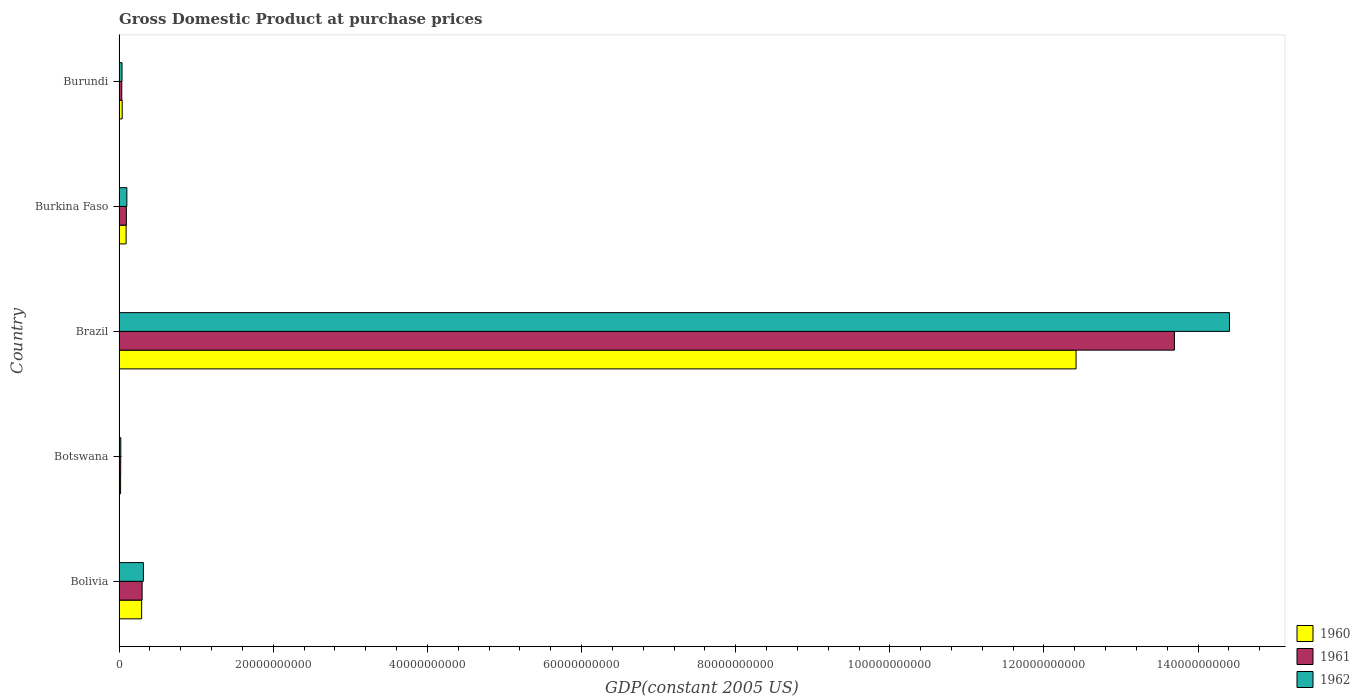How many groups of bars are there?
Your answer should be compact. 5. How many bars are there on the 1st tick from the top?
Make the answer very short. 3. How many bars are there on the 4th tick from the bottom?
Your answer should be compact. 3. What is the label of the 4th group of bars from the top?
Make the answer very short. Botswana. What is the GDP at purchase prices in 1961 in Burundi?
Your answer should be very brief. 3.53e+08. Across all countries, what is the maximum GDP at purchase prices in 1962?
Your response must be concise. 1.44e+11. Across all countries, what is the minimum GDP at purchase prices in 1961?
Your answer should be very brief. 2.12e+08. In which country was the GDP at purchase prices in 1962 minimum?
Your answer should be compact. Botswana. What is the total GDP at purchase prices in 1961 in the graph?
Ensure brevity in your answer.  1.41e+11. What is the difference between the GDP at purchase prices in 1962 in Botswana and that in Brazil?
Offer a very short reply. -1.44e+11. What is the difference between the GDP at purchase prices in 1961 in Burkina Faso and the GDP at purchase prices in 1962 in Burundi?
Give a very brief answer. 5.69e+08. What is the average GDP at purchase prices in 1960 per country?
Give a very brief answer. 2.57e+1. What is the difference between the GDP at purchase prices in 1961 and GDP at purchase prices in 1962 in Brazil?
Your answer should be very brief. -7.14e+09. What is the ratio of the GDP at purchase prices in 1960 in Brazil to that in Burundi?
Provide a succinct answer. 303.09. What is the difference between the highest and the second highest GDP at purchase prices in 1960?
Give a very brief answer. 1.21e+11. What is the difference between the highest and the lowest GDP at purchase prices in 1961?
Provide a short and direct response. 1.37e+11. Is the sum of the GDP at purchase prices in 1962 in Brazil and Burundi greater than the maximum GDP at purchase prices in 1960 across all countries?
Give a very brief answer. Yes. What does the 2nd bar from the top in Brazil represents?
Give a very brief answer. 1961. Is it the case that in every country, the sum of the GDP at purchase prices in 1961 and GDP at purchase prices in 1962 is greater than the GDP at purchase prices in 1960?
Your answer should be compact. Yes. Are all the bars in the graph horizontal?
Provide a succinct answer. Yes. How many countries are there in the graph?
Offer a terse response. 5. How many legend labels are there?
Provide a succinct answer. 3. What is the title of the graph?
Make the answer very short. Gross Domestic Product at purchase prices. Does "2012" appear as one of the legend labels in the graph?
Your answer should be compact. No. What is the label or title of the X-axis?
Offer a terse response. GDP(constant 2005 US). What is the GDP(constant 2005 US) in 1960 in Bolivia?
Ensure brevity in your answer.  2.93e+09. What is the GDP(constant 2005 US) in 1961 in Bolivia?
Make the answer very short. 2.99e+09. What is the GDP(constant 2005 US) in 1962 in Bolivia?
Provide a short and direct response. 3.16e+09. What is the GDP(constant 2005 US) in 1960 in Botswana?
Make the answer very short. 1.99e+08. What is the GDP(constant 2005 US) in 1961 in Botswana?
Your response must be concise. 2.12e+08. What is the GDP(constant 2005 US) of 1962 in Botswana?
Your answer should be very brief. 2.26e+08. What is the GDP(constant 2005 US) of 1960 in Brazil?
Keep it short and to the point. 1.24e+11. What is the GDP(constant 2005 US) in 1961 in Brazil?
Give a very brief answer. 1.37e+11. What is the GDP(constant 2005 US) of 1962 in Brazil?
Provide a short and direct response. 1.44e+11. What is the GDP(constant 2005 US) in 1960 in Burkina Faso?
Make the answer very short. 9.17e+08. What is the GDP(constant 2005 US) of 1961 in Burkina Faso?
Offer a terse response. 9.54e+08. What is the GDP(constant 2005 US) in 1962 in Burkina Faso?
Ensure brevity in your answer.  1.01e+09. What is the GDP(constant 2005 US) of 1960 in Burundi?
Provide a short and direct response. 4.10e+08. What is the GDP(constant 2005 US) of 1961 in Burundi?
Ensure brevity in your answer.  3.53e+08. What is the GDP(constant 2005 US) in 1962 in Burundi?
Keep it short and to the point. 3.85e+08. Across all countries, what is the maximum GDP(constant 2005 US) in 1960?
Provide a succinct answer. 1.24e+11. Across all countries, what is the maximum GDP(constant 2005 US) of 1961?
Your response must be concise. 1.37e+11. Across all countries, what is the maximum GDP(constant 2005 US) in 1962?
Keep it short and to the point. 1.44e+11. Across all countries, what is the minimum GDP(constant 2005 US) of 1960?
Provide a short and direct response. 1.99e+08. Across all countries, what is the minimum GDP(constant 2005 US) in 1961?
Your answer should be very brief. 2.12e+08. Across all countries, what is the minimum GDP(constant 2005 US) in 1962?
Offer a very short reply. 2.26e+08. What is the total GDP(constant 2005 US) in 1960 in the graph?
Your answer should be very brief. 1.29e+11. What is the total GDP(constant 2005 US) of 1961 in the graph?
Offer a terse response. 1.41e+11. What is the total GDP(constant 2005 US) of 1962 in the graph?
Provide a short and direct response. 1.49e+11. What is the difference between the GDP(constant 2005 US) of 1960 in Bolivia and that in Botswana?
Give a very brief answer. 2.73e+09. What is the difference between the GDP(constant 2005 US) of 1961 in Bolivia and that in Botswana?
Your response must be concise. 2.78e+09. What is the difference between the GDP(constant 2005 US) of 1962 in Bolivia and that in Botswana?
Provide a succinct answer. 2.93e+09. What is the difference between the GDP(constant 2005 US) of 1960 in Bolivia and that in Brazil?
Your response must be concise. -1.21e+11. What is the difference between the GDP(constant 2005 US) in 1961 in Bolivia and that in Brazil?
Provide a short and direct response. -1.34e+11. What is the difference between the GDP(constant 2005 US) in 1962 in Bolivia and that in Brazil?
Offer a terse response. -1.41e+11. What is the difference between the GDP(constant 2005 US) in 1960 in Bolivia and that in Burkina Faso?
Your answer should be compact. 2.01e+09. What is the difference between the GDP(constant 2005 US) in 1961 in Bolivia and that in Burkina Faso?
Provide a succinct answer. 2.04e+09. What is the difference between the GDP(constant 2005 US) of 1962 in Bolivia and that in Burkina Faso?
Provide a short and direct response. 2.15e+09. What is the difference between the GDP(constant 2005 US) in 1960 in Bolivia and that in Burundi?
Provide a short and direct response. 2.52e+09. What is the difference between the GDP(constant 2005 US) in 1961 in Bolivia and that in Burundi?
Make the answer very short. 2.64e+09. What is the difference between the GDP(constant 2005 US) of 1962 in Bolivia and that in Burundi?
Keep it short and to the point. 2.77e+09. What is the difference between the GDP(constant 2005 US) of 1960 in Botswana and that in Brazil?
Offer a very short reply. -1.24e+11. What is the difference between the GDP(constant 2005 US) in 1961 in Botswana and that in Brazil?
Your answer should be very brief. -1.37e+11. What is the difference between the GDP(constant 2005 US) of 1962 in Botswana and that in Brazil?
Offer a very short reply. -1.44e+11. What is the difference between the GDP(constant 2005 US) of 1960 in Botswana and that in Burkina Faso?
Your answer should be very brief. -7.18e+08. What is the difference between the GDP(constant 2005 US) in 1961 in Botswana and that in Burkina Faso?
Give a very brief answer. -7.42e+08. What is the difference between the GDP(constant 2005 US) of 1962 in Botswana and that in Burkina Faso?
Your response must be concise. -7.87e+08. What is the difference between the GDP(constant 2005 US) of 1960 in Botswana and that in Burundi?
Keep it short and to the point. -2.11e+08. What is the difference between the GDP(constant 2005 US) in 1961 in Botswana and that in Burundi?
Keep it short and to the point. -1.42e+08. What is the difference between the GDP(constant 2005 US) of 1962 in Botswana and that in Burundi?
Provide a short and direct response. -1.60e+08. What is the difference between the GDP(constant 2005 US) in 1960 in Brazil and that in Burkina Faso?
Offer a terse response. 1.23e+11. What is the difference between the GDP(constant 2005 US) in 1961 in Brazil and that in Burkina Faso?
Your answer should be compact. 1.36e+11. What is the difference between the GDP(constant 2005 US) of 1962 in Brazil and that in Burkina Faso?
Provide a succinct answer. 1.43e+11. What is the difference between the GDP(constant 2005 US) of 1960 in Brazil and that in Burundi?
Keep it short and to the point. 1.24e+11. What is the difference between the GDP(constant 2005 US) of 1961 in Brazil and that in Burundi?
Your answer should be compact. 1.37e+11. What is the difference between the GDP(constant 2005 US) in 1962 in Brazil and that in Burundi?
Give a very brief answer. 1.44e+11. What is the difference between the GDP(constant 2005 US) of 1960 in Burkina Faso and that in Burundi?
Make the answer very short. 5.07e+08. What is the difference between the GDP(constant 2005 US) in 1961 in Burkina Faso and that in Burundi?
Your response must be concise. 6.01e+08. What is the difference between the GDP(constant 2005 US) of 1962 in Burkina Faso and that in Burundi?
Your answer should be compact. 6.27e+08. What is the difference between the GDP(constant 2005 US) of 1960 in Bolivia and the GDP(constant 2005 US) of 1961 in Botswana?
Provide a short and direct response. 2.72e+09. What is the difference between the GDP(constant 2005 US) of 1960 in Bolivia and the GDP(constant 2005 US) of 1962 in Botswana?
Provide a short and direct response. 2.71e+09. What is the difference between the GDP(constant 2005 US) in 1961 in Bolivia and the GDP(constant 2005 US) in 1962 in Botswana?
Ensure brevity in your answer.  2.77e+09. What is the difference between the GDP(constant 2005 US) of 1960 in Bolivia and the GDP(constant 2005 US) of 1961 in Brazil?
Provide a succinct answer. -1.34e+11. What is the difference between the GDP(constant 2005 US) of 1960 in Bolivia and the GDP(constant 2005 US) of 1962 in Brazil?
Your answer should be compact. -1.41e+11. What is the difference between the GDP(constant 2005 US) in 1961 in Bolivia and the GDP(constant 2005 US) in 1962 in Brazil?
Your answer should be compact. -1.41e+11. What is the difference between the GDP(constant 2005 US) in 1960 in Bolivia and the GDP(constant 2005 US) in 1961 in Burkina Faso?
Provide a succinct answer. 1.98e+09. What is the difference between the GDP(constant 2005 US) of 1960 in Bolivia and the GDP(constant 2005 US) of 1962 in Burkina Faso?
Provide a short and direct response. 1.92e+09. What is the difference between the GDP(constant 2005 US) of 1961 in Bolivia and the GDP(constant 2005 US) of 1962 in Burkina Faso?
Your answer should be compact. 1.98e+09. What is the difference between the GDP(constant 2005 US) in 1960 in Bolivia and the GDP(constant 2005 US) in 1961 in Burundi?
Keep it short and to the point. 2.58e+09. What is the difference between the GDP(constant 2005 US) of 1960 in Bolivia and the GDP(constant 2005 US) of 1962 in Burundi?
Provide a short and direct response. 2.55e+09. What is the difference between the GDP(constant 2005 US) of 1961 in Bolivia and the GDP(constant 2005 US) of 1962 in Burundi?
Your answer should be compact. 2.61e+09. What is the difference between the GDP(constant 2005 US) in 1960 in Botswana and the GDP(constant 2005 US) in 1961 in Brazil?
Ensure brevity in your answer.  -1.37e+11. What is the difference between the GDP(constant 2005 US) of 1960 in Botswana and the GDP(constant 2005 US) of 1962 in Brazil?
Your response must be concise. -1.44e+11. What is the difference between the GDP(constant 2005 US) in 1961 in Botswana and the GDP(constant 2005 US) in 1962 in Brazil?
Your answer should be very brief. -1.44e+11. What is the difference between the GDP(constant 2005 US) of 1960 in Botswana and the GDP(constant 2005 US) of 1961 in Burkina Faso?
Keep it short and to the point. -7.55e+08. What is the difference between the GDP(constant 2005 US) of 1960 in Botswana and the GDP(constant 2005 US) of 1962 in Burkina Faso?
Ensure brevity in your answer.  -8.14e+08. What is the difference between the GDP(constant 2005 US) of 1961 in Botswana and the GDP(constant 2005 US) of 1962 in Burkina Faso?
Provide a succinct answer. -8.01e+08. What is the difference between the GDP(constant 2005 US) of 1960 in Botswana and the GDP(constant 2005 US) of 1961 in Burundi?
Make the answer very short. -1.54e+08. What is the difference between the GDP(constant 2005 US) of 1960 in Botswana and the GDP(constant 2005 US) of 1962 in Burundi?
Offer a very short reply. -1.86e+08. What is the difference between the GDP(constant 2005 US) of 1961 in Botswana and the GDP(constant 2005 US) of 1962 in Burundi?
Offer a very short reply. -1.74e+08. What is the difference between the GDP(constant 2005 US) of 1960 in Brazil and the GDP(constant 2005 US) of 1961 in Burkina Faso?
Your response must be concise. 1.23e+11. What is the difference between the GDP(constant 2005 US) in 1960 in Brazil and the GDP(constant 2005 US) in 1962 in Burkina Faso?
Provide a succinct answer. 1.23e+11. What is the difference between the GDP(constant 2005 US) of 1961 in Brazil and the GDP(constant 2005 US) of 1962 in Burkina Faso?
Ensure brevity in your answer.  1.36e+11. What is the difference between the GDP(constant 2005 US) of 1960 in Brazil and the GDP(constant 2005 US) of 1961 in Burundi?
Provide a succinct answer. 1.24e+11. What is the difference between the GDP(constant 2005 US) in 1960 in Brazil and the GDP(constant 2005 US) in 1962 in Burundi?
Your response must be concise. 1.24e+11. What is the difference between the GDP(constant 2005 US) of 1961 in Brazil and the GDP(constant 2005 US) of 1962 in Burundi?
Provide a short and direct response. 1.37e+11. What is the difference between the GDP(constant 2005 US) of 1960 in Burkina Faso and the GDP(constant 2005 US) of 1961 in Burundi?
Ensure brevity in your answer.  5.64e+08. What is the difference between the GDP(constant 2005 US) in 1960 in Burkina Faso and the GDP(constant 2005 US) in 1962 in Burundi?
Make the answer very short. 5.32e+08. What is the difference between the GDP(constant 2005 US) in 1961 in Burkina Faso and the GDP(constant 2005 US) in 1962 in Burundi?
Your answer should be compact. 5.69e+08. What is the average GDP(constant 2005 US) in 1960 per country?
Keep it short and to the point. 2.57e+1. What is the average GDP(constant 2005 US) in 1961 per country?
Provide a short and direct response. 2.83e+1. What is the average GDP(constant 2005 US) of 1962 per country?
Make the answer very short. 2.98e+1. What is the difference between the GDP(constant 2005 US) in 1960 and GDP(constant 2005 US) in 1961 in Bolivia?
Offer a terse response. -6.10e+07. What is the difference between the GDP(constant 2005 US) of 1960 and GDP(constant 2005 US) of 1962 in Bolivia?
Offer a very short reply. -2.28e+08. What is the difference between the GDP(constant 2005 US) of 1961 and GDP(constant 2005 US) of 1962 in Bolivia?
Offer a very short reply. -1.67e+08. What is the difference between the GDP(constant 2005 US) of 1960 and GDP(constant 2005 US) of 1961 in Botswana?
Your response must be concise. -1.26e+07. What is the difference between the GDP(constant 2005 US) in 1960 and GDP(constant 2005 US) in 1962 in Botswana?
Keep it short and to the point. -2.67e+07. What is the difference between the GDP(constant 2005 US) in 1961 and GDP(constant 2005 US) in 1962 in Botswana?
Offer a terse response. -1.41e+07. What is the difference between the GDP(constant 2005 US) of 1960 and GDP(constant 2005 US) of 1961 in Brazil?
Give a very brief answer. -1.28e+1. What is the difference between the GDP(constant 2005 US) of 1960 and GDP(constant 2005 US) of 1962 in Brazil?
Provide a short and direct response. -1.99e+1. What is the difference between the GDP(constant 2005 US) in 1961 and GDP(constant 2005 US) in 1962 in Brazil?
Give a very brief answer. -7.14e+09. What is the difference between the GDP(constant 2005 US) of 1960 and GDP(constant 2005 US) of 1961 in Burkina Faso?
Your answer should be very brief. -3.71e+07. What is the difference between the GDP(constant 2005 US) of 1960 and GDP(constant 2005 US) of 1962 in Burkina Faso?
Give a very brief answer. -9.56e+07. What is the difference between the GDP(constant 2005 US) in 1961 and GDP(constant 2005 US) in 1962 in Burkina Faso?
Offer a very short reply. -5.85e+07. What is the difference between the GDP(constant 2005 US) of 1960 and GDP(constant 2005 US) of 1961 in Burundi?
Give a very brief answer. 5.63e+07. What is the difference between the GDP(constant 2005 US) of 1960 and GDP(constant 2005 US) of 1962 in Burundi?
Ensure brevity in your answer.  2.43e+07. What is the difference between the GDP(constant 2005 US) of 1961 and GDP(constant 2005 US) of 1962 in Burundi?
Give a very brief answer. -3.20e+07. What is the ratio of the GDP(constant 2005 US) in 1960 in Bolivia to that in Botswana?
Make the answer very short. 14.73. What is the ratio of the GDP(constant 2005 US) in 1961 in Bolivia to that in Botswana?
Give a very brief answer. 14.14. What is the ratio of the GDP(constant 2005 US) in 1962 in Bolivia to that in Botswana?
Provide a succinct answer. 14. What is the ratio of the GDP(constant 2005 US) in 1960 in Bolivia to that in Brazil?
Offer a very short reply. 0.02. What is the ratio of the GDP(constant 2005 US) in 1961 in Bolivia to that in Brazil?
Your answer should be compact. 0.02. What is the ratio of the GDP(constant 2005 US) of 1962 in Bolivia to that in Brazil?
Ensure brevity in your answer.  0.02. What is the ratio of the GDP(constant 2005 US) of 1960 in Bolivia to that in Burkina Faso?
Your response must be concise. 3.2. What is the ratio of the GDP(constant 2005 US) in 1961 in Bolivia to that in Burkina Faso?
Provide a succinct answer. 3.14. What is the ratio of the GDP(constant 2005 US) in 1962 in Bolivia to that in Burkina Faso?
Ensure brevity in your answer.  3.12. What is the ratio of the GDP(constant 2005 US) in 1960 in Bolivia to that in Burundi?
Give a very brief answer. 7.16. What is the ratio of the GDP(constant 2005 US) in 1961 in Bolivia to that in Burundi?
Ensure brevity in your answer.  8.47. What is the ratio of the GDP(constant 2005 US) in 1962 in Bolivia to that in Burundi?
Ensure brevity in your answer.  8.2. What is the ratio of the GDP(constant 2005 US) of 1960 in Botswana to that in Brazil?
Offer a terse response. 0. What is the ratio of the GDP(constant 2005 US) of 1961 in Botswana to that in Brazil?
Ensure brevity in your answer.  0. What is the ratio of the GDP(constant 2005 US) in 1962 in Botswana to that in Brazil?
Provide a short and direct response. 0. What is the ratio of the GDP(constant 2005 US) in 1960 in Botswana to that in Burkina Faso?
Offer a very short reply. 0.22. What is the ratio of the GDP(constant 2005 US) of 1961 in Botswana to that in Burkina Faso?
Make the answer very short. 0.22. What is the ratio of the GDP(constant 2005 US) of 1962 in Botswana to that in Burkina Faso?
Your response must be concise. 0.22. What is the ratio of the GDP(constant 2005 US) in 1960 in Botswana to that in Burundi?
Your answer should be very brief. 0.49. What is the ratio of the GDP(constant 2005 US) in 1961 in Botswana to that in Burundi?
Provide a succinct answer. 0.6. What is the ratio of the GDP(constant 2005 US) of 1962 in Botswana to that in Burundi?
Provide a succinct answer. 0.59. What is the ratio of the GDP(constant 2005 US) of 1960 in Brazil to that in Burkina Faso?
Your answer should be compact. 135.4. What is the ratio of the GDP(constant 2005 US) of 1961 in Brazil to that in Burkina Faso?
Ensure brevity in your answer.  143.51. What is the ratio of the GDP(constant 2005 US) of 1962 in Brazil to that in Burkina Faso?
Keep it short and to the point. 142.28. What is the ratio of the GDP(constant 2005 US) of 1960 in Brazil to that in Burundi?
Make the answer very short. 303.09. What is the ratio of the GDP(constant 2005 US) in 1961 in Brazil to that in Burundi?
Your answer should be compact. 387.5. What is the ratio of the GDP(constant 2005 US) in 1962 in Brazil to that in Burundi?
Your answer should be very brief. 373.83. What is the ratio of the GDP(constant 2005 US) in 1960 in Burkina Faso to that in Burundi?
Offer a very short reply. 2.24. What is the ratio of the GDP(constant 2005 US) of 1961 in Burkina Faso to that in Burundi?
Ensure brevity in your answer.  2.7. What is the ratio of the GDP(constant 2005 US) of 1962 in Burkina Faso to that in Burundi?
Make the answer very short. 2.63. What is the difference between the highest and the second highest GDP(constant 2005 US) of 1960?
Give a very brief answer. 1.21e+11. What is the difference between the highest and the second highest GDP(constant 2005 US) of 1961?
Keep it short and to the point. 1.34e+11. What is the difference between the highest and the second highest GDP(constant 2005 US) in 1962?
Your answer should be very brief. 1.41e+11. What is the difference between the highest and the lowest GDP(constant 2005 US) in 1960?
Provide a short and direct response. 1.24e+11. What is the difference between the highest and the lowest GDP(constant 2005 US) of 1961?
Your response must be concise. 1.37e+11. What is the difference between the highest and the lowest GDP(constant 2005 US) in 1962?
Keep it short and to the point. 1.44e+11. 